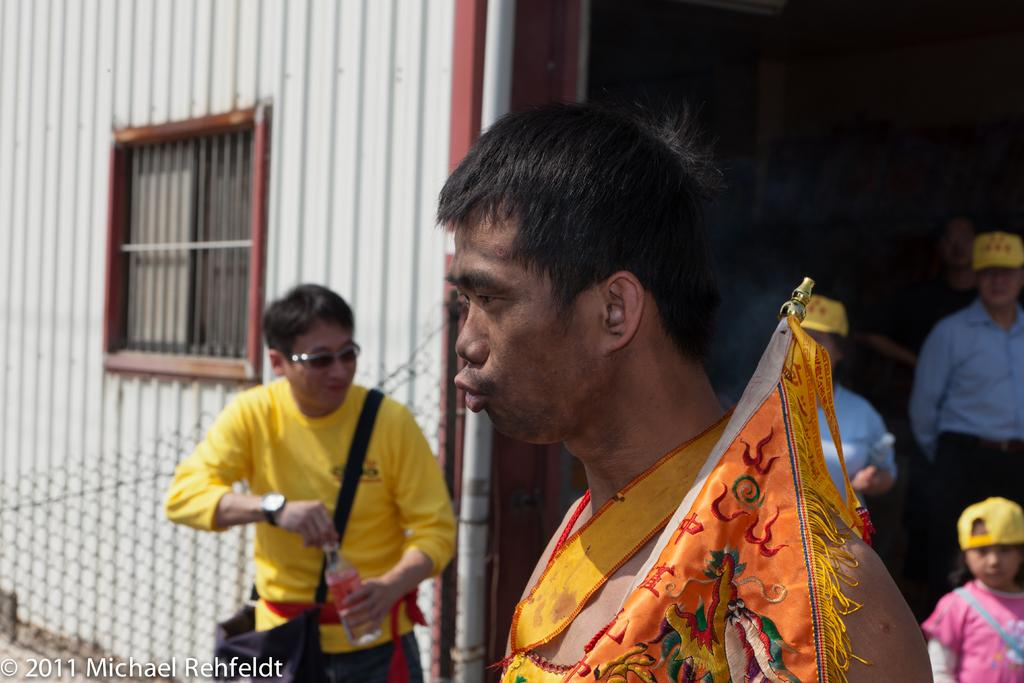Who or what can be seen in the image? There are people in the image. What is the prominent feature in the image? There is a flag in the image. Can you describe the background of the image? In the background of the image, there are iron sheets, windows, a fence, and other objects. What type of oranges are being harvested in the plantation shown in the image? There is no plantation or oranges present in the image. What boundary is depicted in the image? There is no boundary depicted in the image. 